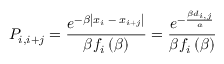<formula> <loc_0><loc_0><loc_500><loc_500>P _ { i , i + j } = \frac { e ^ { - \beta \left | x _ { i } \, - \, x _ { i + j } \right | } } { \beta f _ { i } \left ( \beta \right ) } = \frac { e ^ { - \frac { \beta d _ { i , j } } { a } } } { \beta f _ { i } \left ( \beta \right ) }</formula> 